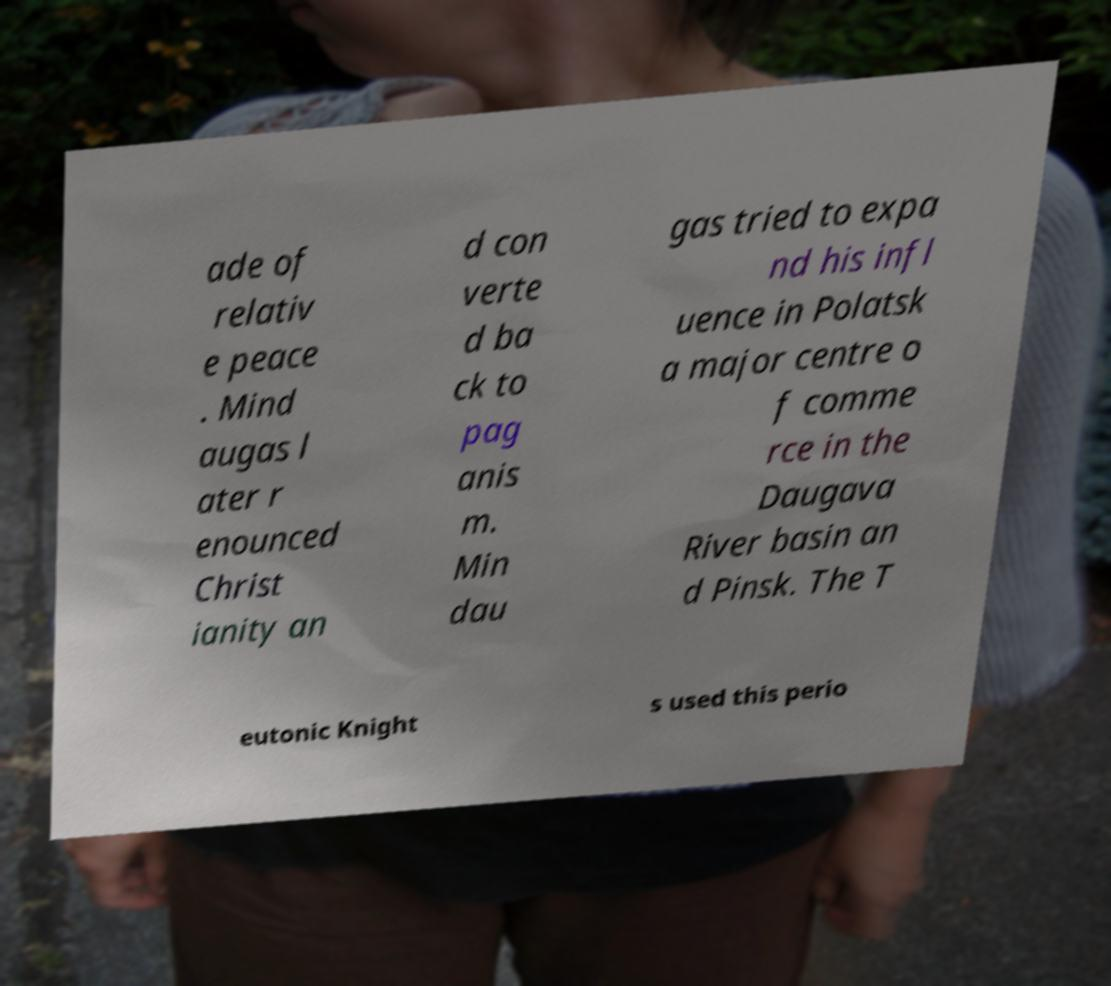Could you extract and type out the text from this image? ade of relativ e peace . Mind augas l ater r enounced Christ ianity an d con verte d ba ck to pag anis m. Min dau gas tried to expa nd his infl uence in Polatsk a major centre o f comme rce in the Daugava River basin an d Pinsk. The T eutonic Knight s used this perio 